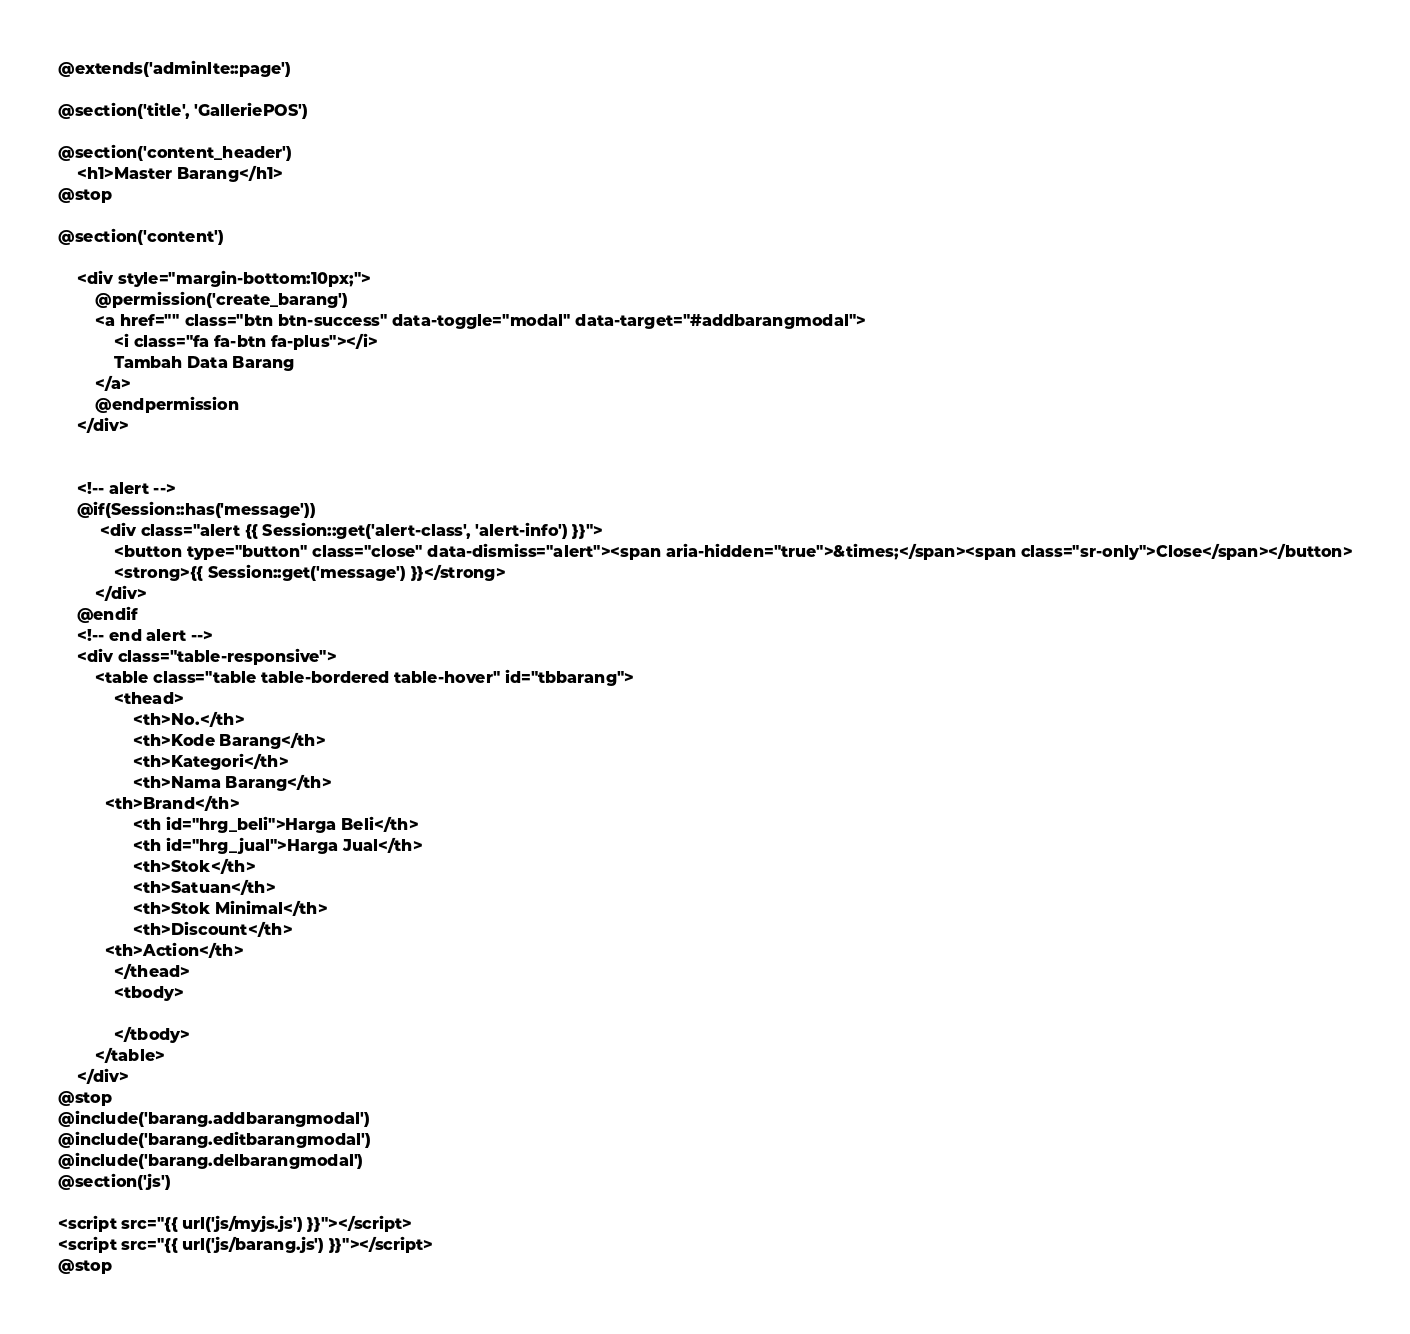Convert code to text. <code><loc_0><loc_0><loc_500><loc_500><_PHP_>@extends('adminlte::page')

@section('title', 'GalleriePOS')

@section('content_header')
    <h1>Master Barang</h1>
@stop

@section('content')

    <div style="margin-bottom:10px;">
        @permission('create_barang')
        <a href="" class="btn btn-success" data-toggle="modal" data-target="#addbarangmodal">
            <i class="fa fa-btn fa-plus"></i>
            Tambah Data Barang
        </a>
        @endpermission
    </div>


    <!-- alert -->
    @if(Session::has('message'))
         <div class="alert {{ Session::get('alert-class', 'alert-info') }}">
            <button type="button" class="close" data-dismiss="alert"><span aria-hidden="true">&times;</span><span class="sr-only">Close</span></button>
            <strong>{{ Session::get('message') }}</strong>
        </div>
    @endif
    <!-- end alert -->
    <div class="table-responsive">
    	<table class="table table-bordered table-hover" id="tbbarang">
    		<thead>
    			<th>No.</th>
    			<th>Kode Barang</th>
    			<th>Kategori</th>
    			<th>Nama Barang</th>
          <th>Brand</th>
    			<th id="hrg_beli">Harga Beli</th>
    			<th id="hrg_jual">Harga Jual</th>
    			<th>Stok</th>
    			<th>Satuan</th>
    			<th>Stok Minimal</th>
    			<th>Discount</th>
          <th>Action</th>
    		</thead>
    		<tbody>
          
    		</tbody>
    	</table>
    </div>
@stop
@include('barang.addbarangmodal')
@include('barang.editbarangmodal')
@include('barang.delbarangmodal')
@section('js')

<script src="{{ url('js/myjs.js') }}"></script>
<script src="{{ url('js/barang.js') }}"></script>
@stop
</code> 